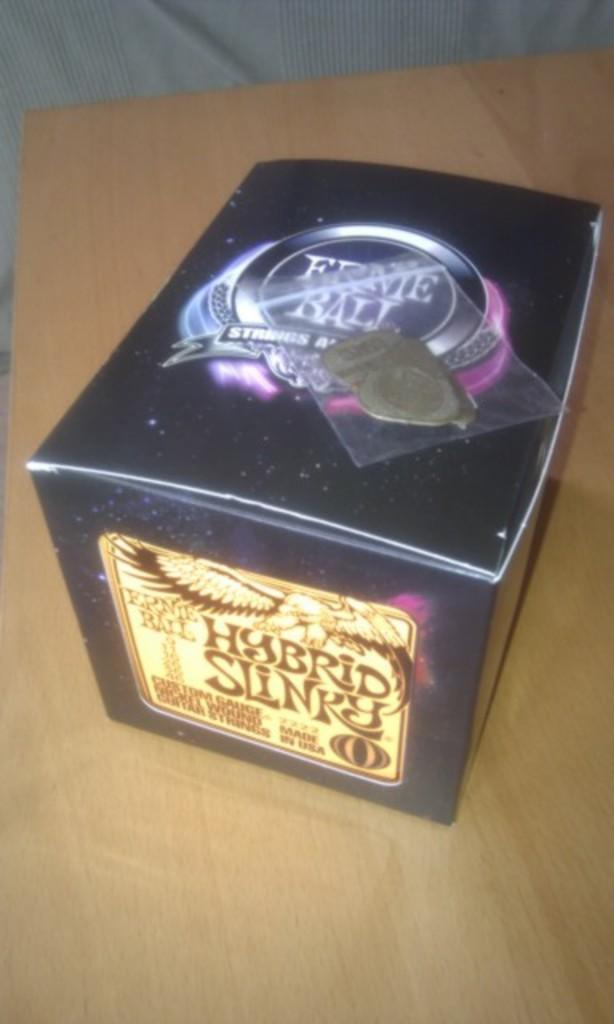Provide a one-sentence caption for the provided image. A box of Ernie Ball custom gauge guitar strings. 